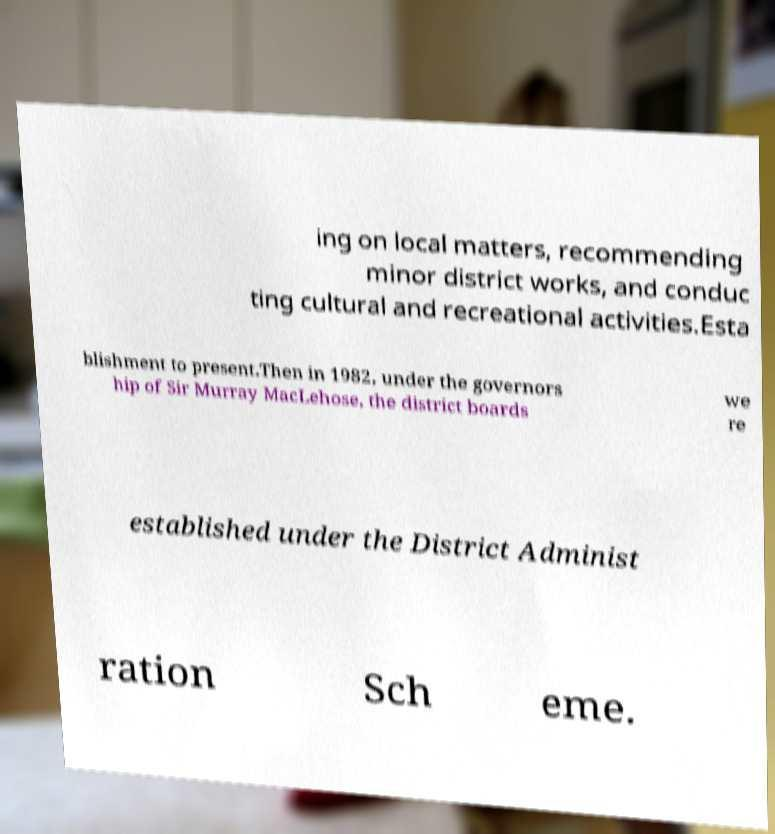Please identify and transcribe the text found in this image. ing on local matters, recommending minor district works, and conduc ting cultural and recreational activities.Esta blishment to present.Then in 1982, under the governors hip of Sir Murray MacLehose, the district boards we re established under the District Administ ration Sch eme. 